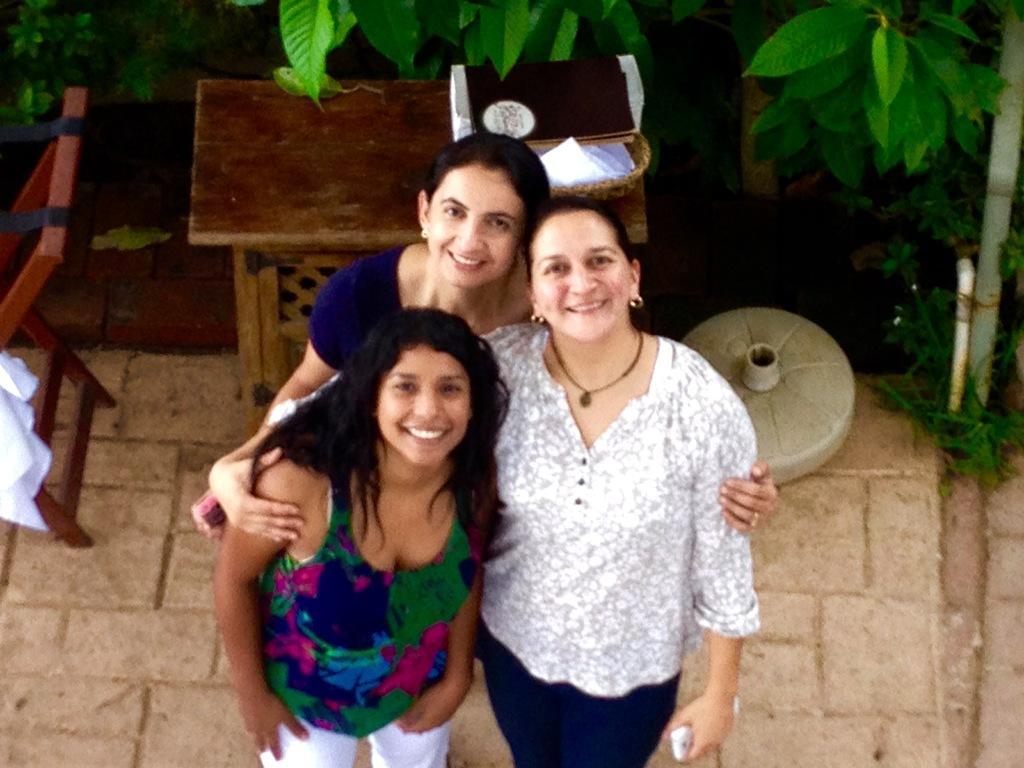Describe this image in one or two sentences. In the image there are three ladies standing. Behind them there is a table with a basket and some other things on it. Beside the table there is an object on the floor. And on the left side of the image there is a wooden object. At the top of the image in the background there are leaves. 